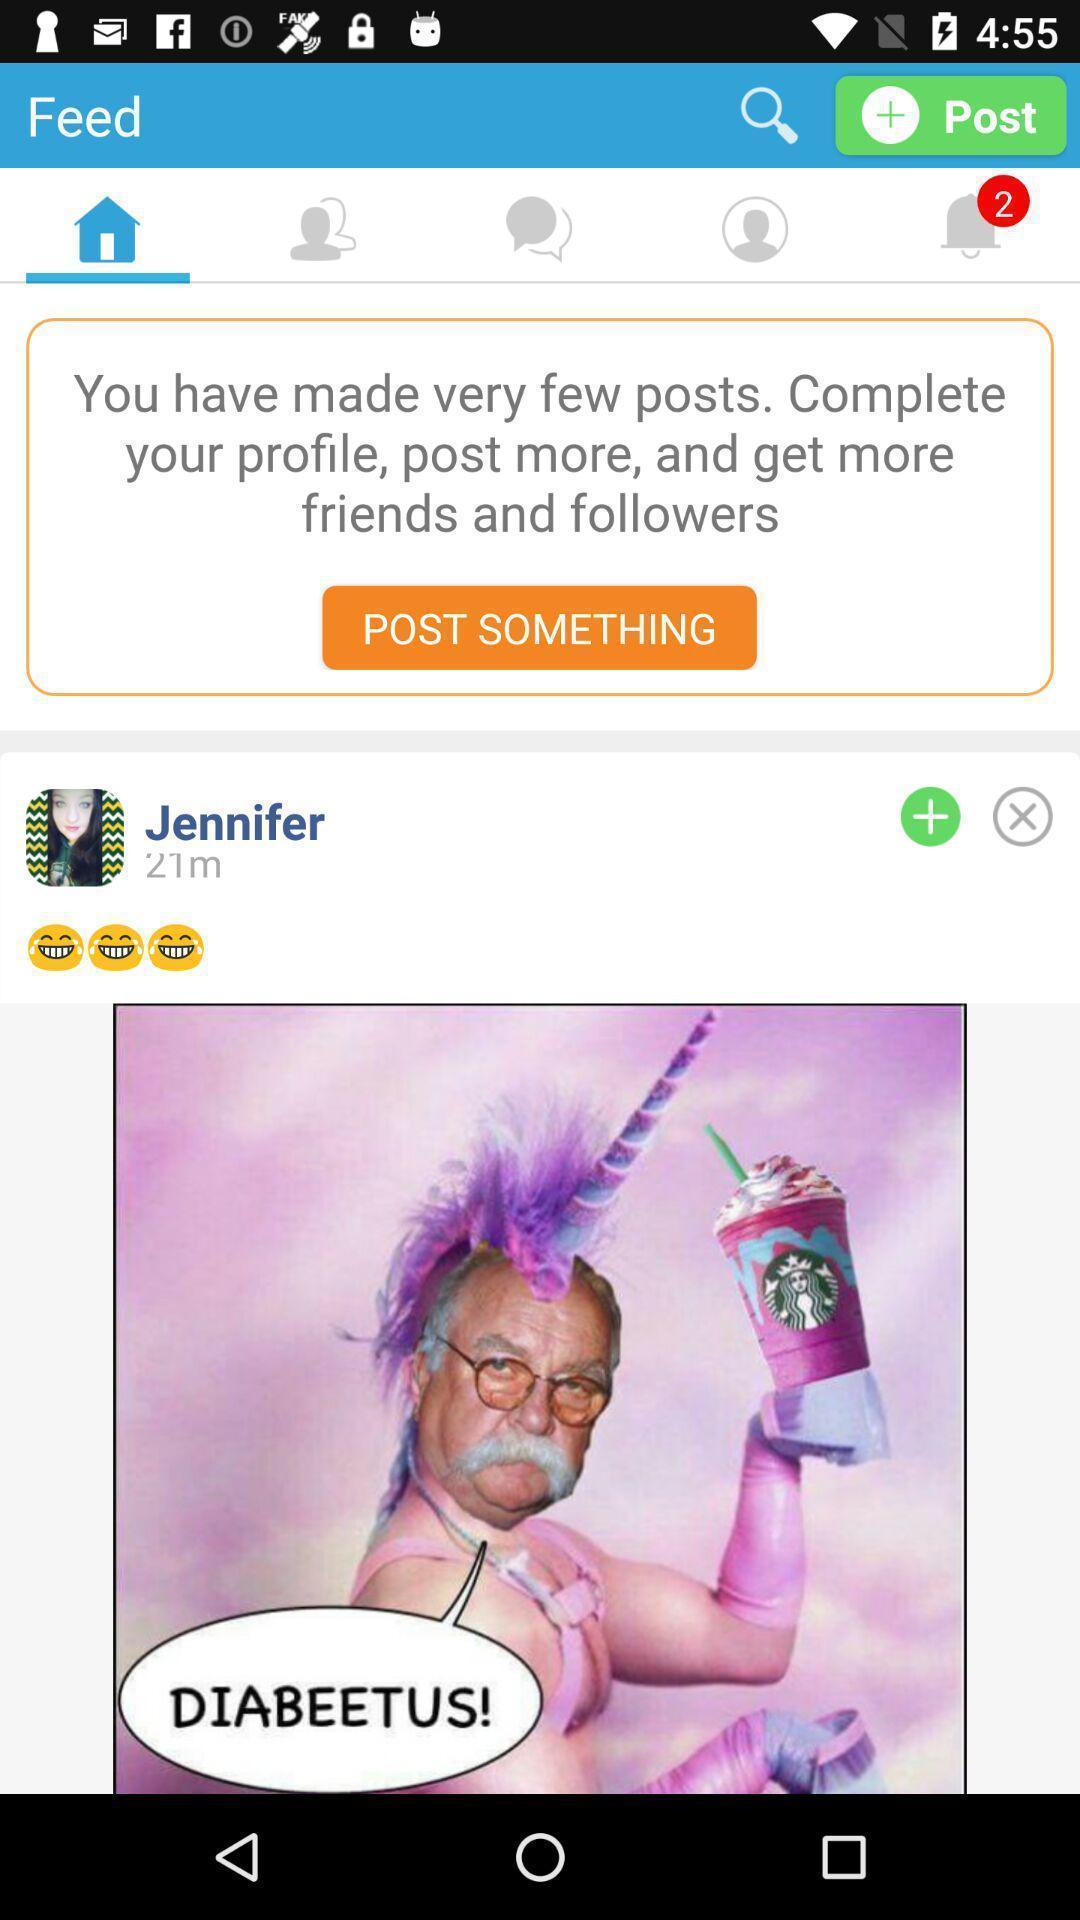Explain what's happening in this screen capture. Screen showing a feed on a social networking app. 